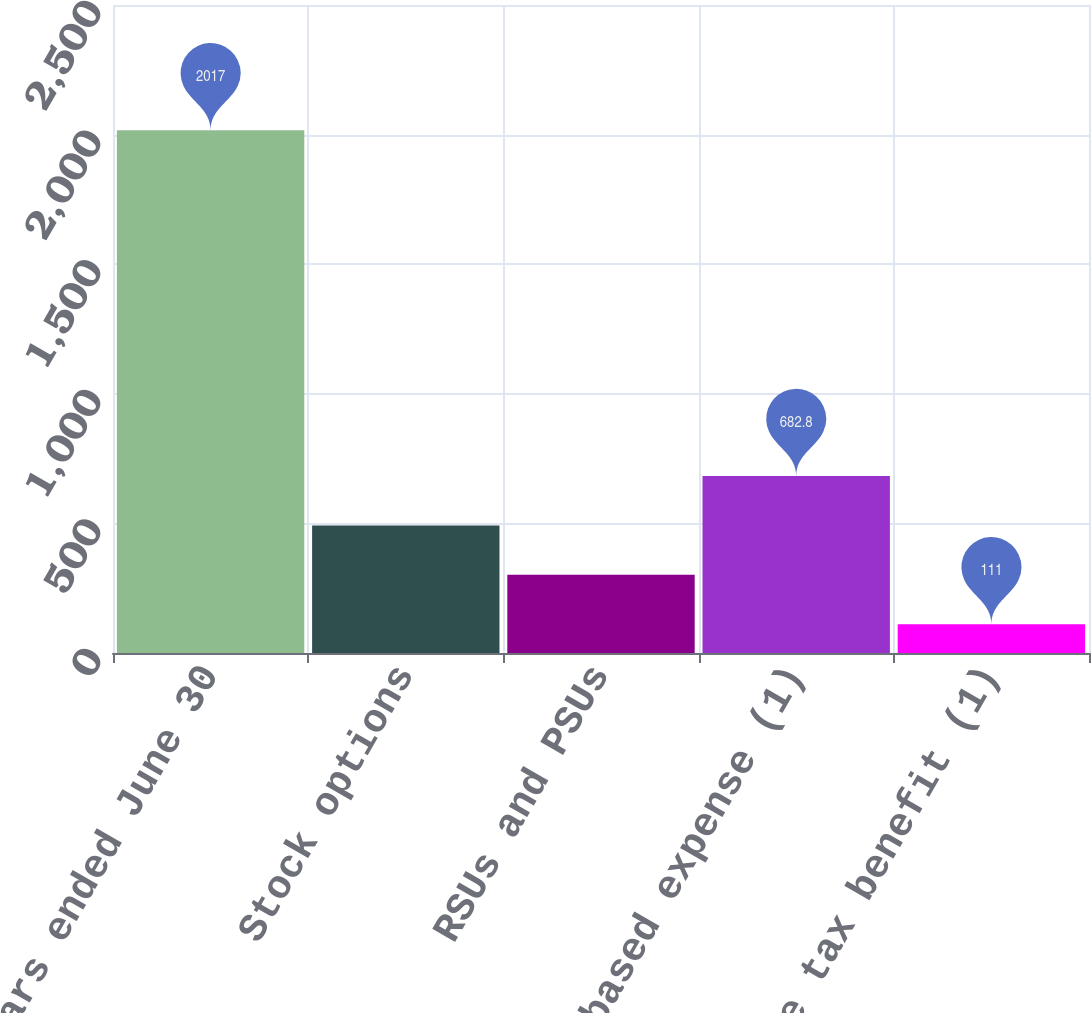Convert chart to OTSL. <chart><loc_0><loc_0><loc_500><loc_500><bar_chart><fcel>Years ended June 30<fcel>Stock options<fcel>RSUs and PSUs<fcel>Total stock-based expense (1)<fcel>Income tax benefit (1)<nl><fcel>2017<fcel>492.2<fcel>301.6<fcel>682.8<fcel>111<nl></chart> 